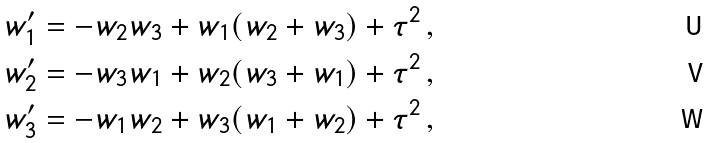<formula> <loc_0><loc_0><loc_500><loc_500>w _ { 1 } ^ { \prime } & = - w _ { 2 } w _ { 3 } + w _ { 1 } ( w _ { 2 } + w _ { 3 } ) + \tau ^ { 2 } \, , \\ w _ { 2 } ^ { \prime } & = - w _ { 3 } w _ { 1 } + w _ { 2 } ( w _ { 3 } + w _ { 1 } ) + \tau ^ { 2 } \, , \\ w _ { 3 } ^ { \prime } & = - w _ { 1 } w _ { 2 } + w _ { 3 } ( w _ { 1 } + w _ { 2 } ) + \tau ^ { 2 } \, ,</formula> 